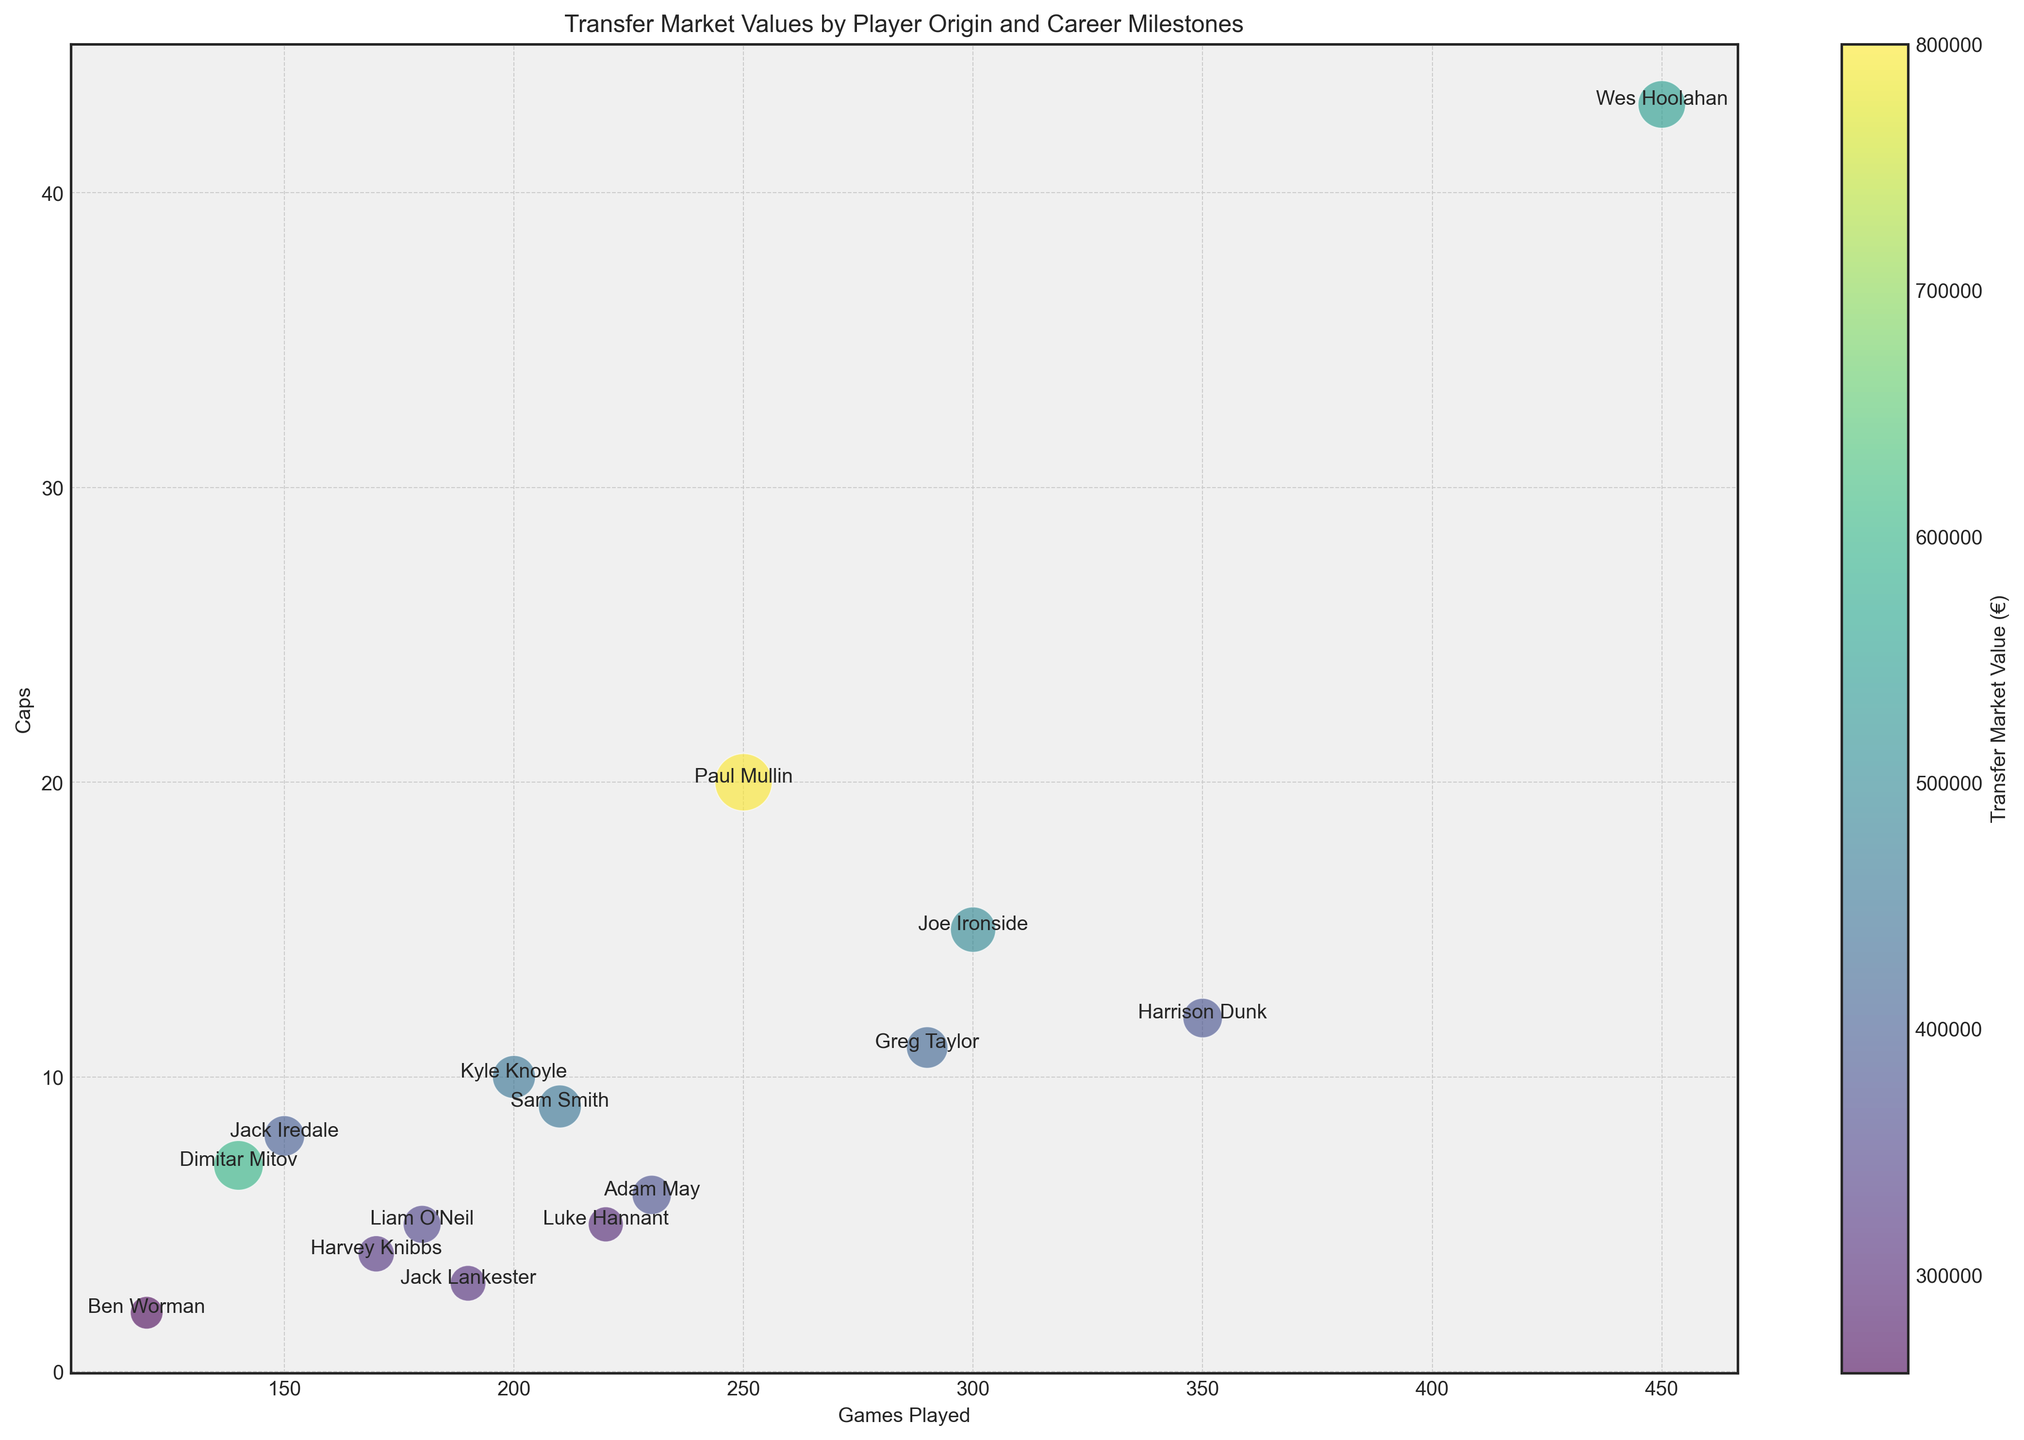Who is represented by the largest bubble? The largest bubble in the figure corresponds to the highest transfer market value. Looking at the plot, the largest bubble represents Paul Mullin.
Answer: Paul Mullin Which player from England has played the most games? Find the bubbles labeled with England and compare the 'games played' attribute. Harrison Dunk stands out with 350 games.
Answer: Harrison Dunk Who has the highest number of caps and what is his transfer market value? Identify the bubble at the highest position on the 'Caps' axis. Wes Hoolahan appears at the top with 43 caps and a transfer market value of €550,000.
Answer: Wes Hoolahan, €550,000 What's the average transfer market value for players originating from England? Select the bubbles labeled with England and sum their transfer values: (500000 + 800000 + 450000 + 380000 + 300000 + 420000 + 350000 + 375000 + 320000 + 450000 + 310000 + 260000). Average is computed as sum divided by count (sum/12).
Answer: €416,250 Which player's bubble is represented with the lightest color and what is his transfer market value? The color bar indicates lighter colors correspond to lower values. Ben Worman has the lightest bubble with a transfer market value of €260,000.
Answer: Ben Worman, €260,000 Which two players have the closest number of caps and what are those values? Compare the 'Caps' values for all bubbles. Joe Ironside (15 caps) and Paul Mullin (20 caps) are the closest.
Answer: Joe Ironside and Paul Mullin, 15 and 20 caps Which player with the least caps has the highest transfer market value? Find the bubble with the lowest value on the 'Caps' axis. Ben Worman (2 caps) has the highest value among players with few caps at €260,000.
Answer: Ben Worman Who has achieved the milestone "Promotion to League One" and what is his transfer market value? Look for the label "Promotion to League One" next to the player's name. Joe Ironside has achieved this milestone with a transfer market value of €500,000.
Answer: Joe Ironside, €500,000 Are there more players with transfer market values above €400,000 or below €400,000? Count the bubbles with transfer values greater than €400,000 and compare them to those below €400,000. There are 10 above €400,000 and 5 below.
Answer: More players with values above €400,000 Which player from Ireland is featured in the plot and what milestone has he achieved? Identify the bubble labeled with Ireland. Wes Hoolahan is featured and his milestone is "Key Player in EFL Trophy Run".
Answer: Wes Hoolahan, Key Player in EFL Trophy Run 